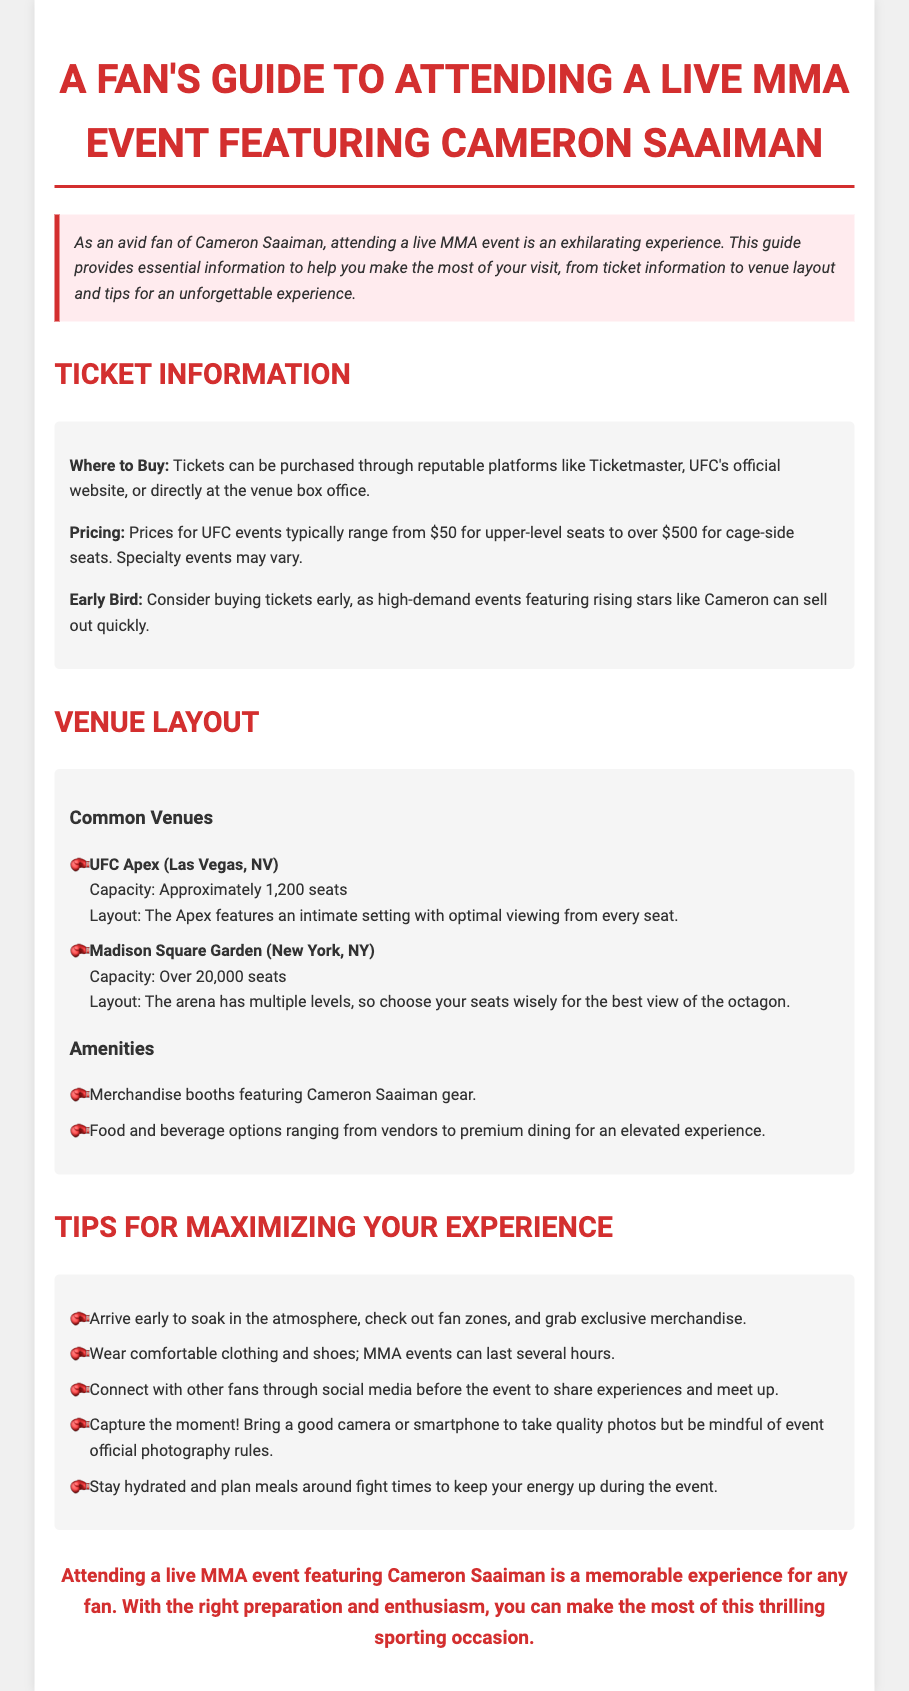what is the maximum capacity of Madison Square Garden? The document states that Madison Square Garden has a capacity of over 20,000 seats.
Answer: over 20,000 seats where can tickets be purchased? According to the document, tickets can be purchased through platforms like Ticketmaster, UFC's official website, or at the venue box office.
Answer: Ticketmaster, UFC's official website, venue box office what should you bring for capturing moments? The guide suggests bringing a good camera or smartphone for quality photos.
Answer: good camera or smartphone how many tips are listed for maximizing the experience? The document mentions five tips provided in the tips section.
Answer: five tips what is the initial ticket price range mentioned? The guide states that prices for UFC events typically range from $50 for upper-level seats to over $500 for cage-side seats.
Answer: $50 to over $500 why is it recommended to arrive early? Arriving early allows you to soak in the atmosphere, explore fan zones, and purchase exclusive merchandise.
Answer: soak in the atmosphere, explore fan zones, purchase exclusive merchandise what type of events may feature rising stars like Cameron Saaiman? The document implies that high-demand events feature rising stars like Cameron.
Answer: high-demand events which venue has an intimate setting? The UFC Apex is noted for its intimate setting with optimal viewing from every seat.
Answer: UFC Apex 